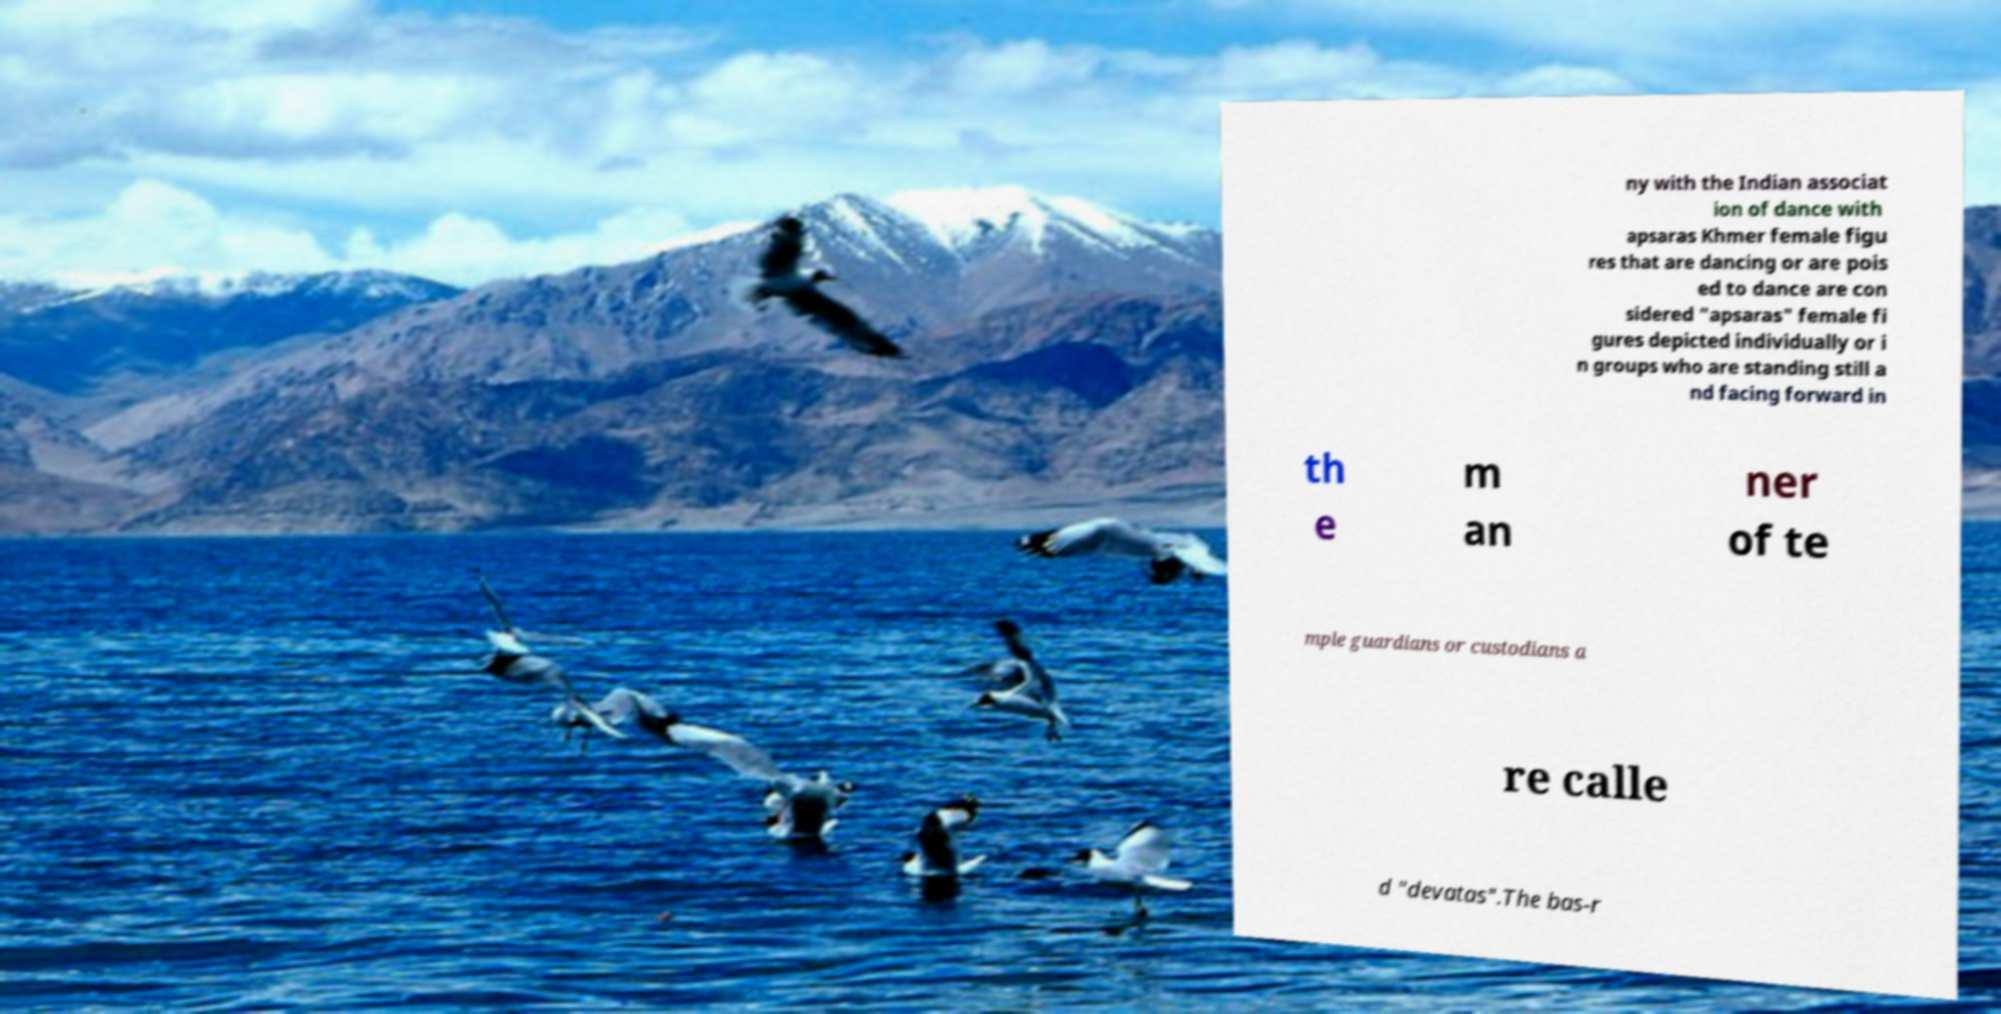What messages or text are displayed in this image? I need them in a readable, typed format. ny with the Indian associat ion of dance with apsaras Khmer female figu res that are dancing or are pois ed to dance are con sidered "apsaras" female fi gures depicted individually or i n groups who are standing still a nd facing forward in th e m an ner of te mple guardians or custodians a re calle d "devatas".The bas-r 